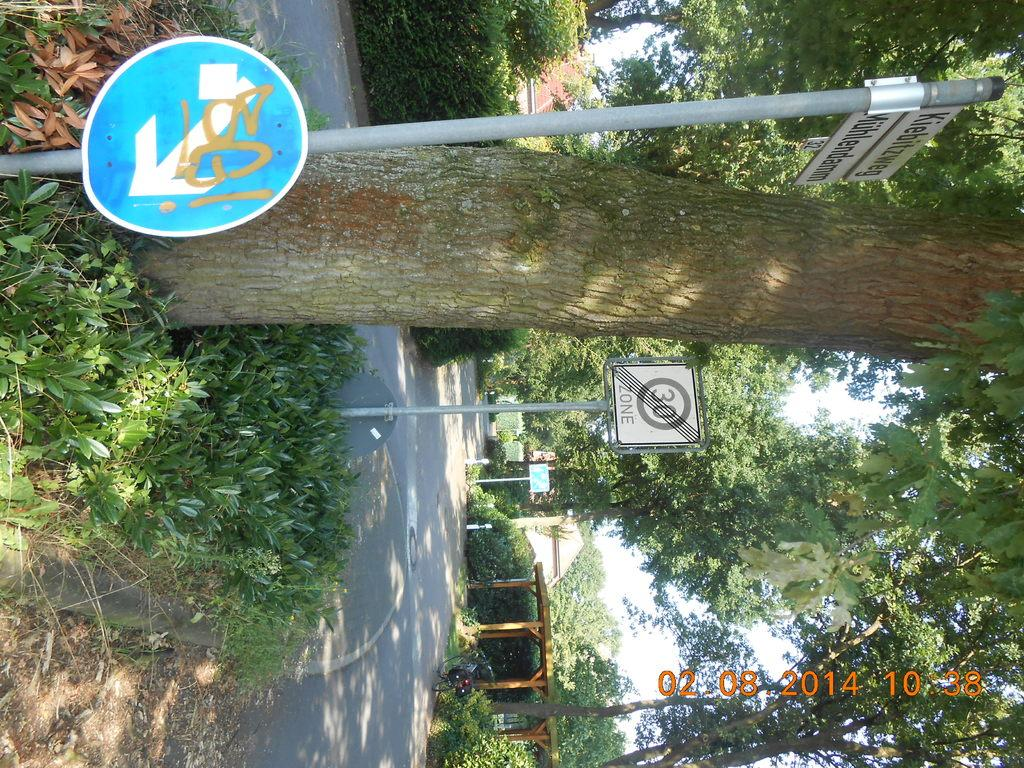<image>
Give a short and clear explanation of the subsequent image. A traffic sign on a tree line road shows it as a 30 zone. 